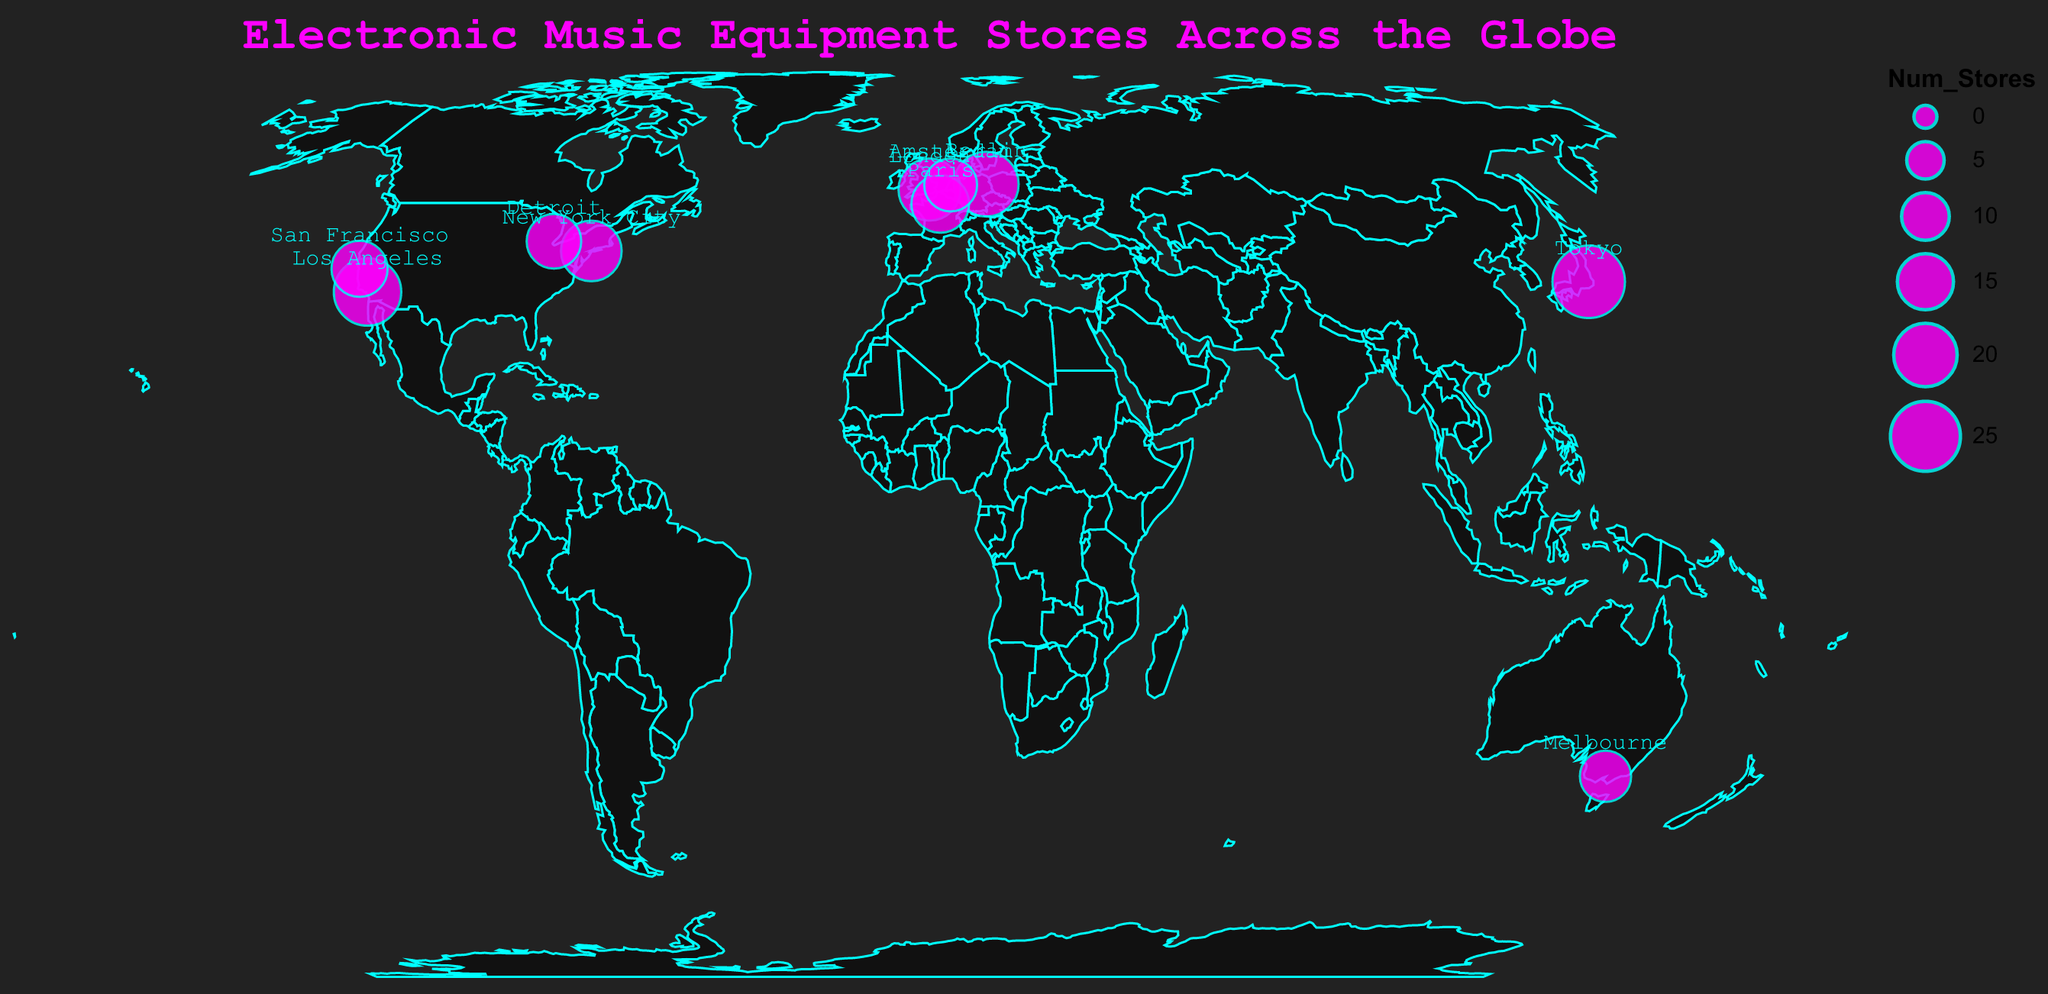What is the title of the plot? The plot title is located at the top of the figure. It summarizes the visual content, providing context about the data shown. Here, the title reads "Electronic Music Equipment Stores Across the Globe".
Answer: Electronic Music Equipment Stores Across the Globe What city has the highest number of electronic music equipment stores? To find out which city has the highest number of stores, look for the largest circle on the map. The tooltip confirms Tokyo has 27 stores, the highest among all the cities listed.
Answer: Tokyo Which store is ranked top in New York City? By hovering over or checking the tooltip for New York City on the map, it shows "Switched On" as the top store in New York City.
Answer: Switched On Compare the number of stores in Los Angeles and Berlin. Which city has more stores? Refer to the circle sizes and tooltips for Los Angeles and Berlin. Los Angeles has 23 stores, whereas Berlin has 21 stores. Thus, Los Angeles has more stores.
Answer: Los Angeles What is the combined number of stores in all the U.S. cities listed on the map? The U.S. cities listed are Los Angeles, New York City, San Francisco, and Detroit. Summing their stores: 23 (Los Angeles) + 18 (New York City) + 15 (San Francisco) + 14 (Detroit) = 70 stores total.
Answer: 70 Which European city is second in the number of stores after Berlin? By looking at the circles and referencing the tooltips for European cities, Berlin has 21 stores (the highest), and next is London with 19 stores.
Answer: London What is the latitude and longitude of Melbourne? Each city’s latitude and longitude can be found by checking the corresponding tooltip. Melbourne’s coordinates are -37.8136, 144.9631.
Answer: -37.8136, 144.9631 How many more stores does Paris have compared to Amsterdam? Paris has 16 stores, and Amsterdam has 13 stores. The difference is calculated as 16 - 13 = 3 stores.
Answer: 3 In which continent is the top store "Store DJ" located? By finding Melbourne on the map and recognizing it is in Australia, you can determine the continent is Australia.
Answer: Australia How many cities in the USA are listed as having electronic music equipment stores? By examining the locations and tooltips on the map, the USA cities listed are Los Angeles, New York City, San Francisco, and Detroit. There are 4 cities total.
Answer: 4 